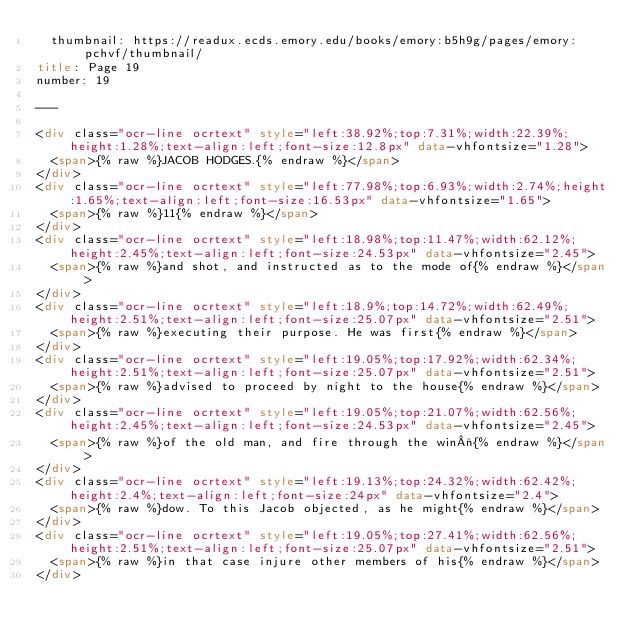Convert code to text. <code><loc_0><loc_0><loc_500><loc_500><_HTML_>  thumbnail: https://readux.ecds.emory.edu/books/emory:b5h9g/pages/emory:pchvf/thumbnail/
title: Page 19
number: 19

---

<div class="ocr-line ocrtext" style="left:38.92%;top:7.31%;width:22.39%;height:1.28%;text-align:left;font-size:12.8px" data-vhfontsize="1.28">
  <span>{% raw %}JACOB HODGES.{% endraw %}</span>
</div>
<div class="ocr-line ocrtext" style="left:77.98%;top:6.93%;width:2.74%;height:1.65%;text-align:left;font-size:16.53px" data-vhfontsize="1.65">
  <span>{% raw %}11{% endraw %}</span>
</div>
<div class="ocr-line ocrtext" style="left:18.98%;top:11.47%;width:62.12%;height:2.45%;text-align:left;font-size:24.53px" data-vhfontsize="2.45">
  <span>{% raw %}and shot, and instructed as to the mode of{% endraw %}</span>
</div>
<div class="ocr-line ocrtext" style="left:18.9%;top:14.72%;width:62.49%;height:2.51%;text-align:left;font-size:25.07px" data-vhfontsize="2.51">
  <span>{% raw %}executing their purpose. He was first{% endraw %}</span>
</div>
<div class="ocr-line ocrtext" style="left:19.05%;top:17.92%;width:62.34%;height:2.51%;text-align:left;font-size:25.07px" data-vhfontsize="2.51">
  <span>{% raw %}advised to proceed by night to the house{% endraw %}</span>
</div>
<div class="ocr-line ocrtext" style="left:19.05%;top:21.07%;width:62.56%;height:2.45%;text-align:left;font-size:24.53px" data-vhfontsize="2.45">
  <span>{% raw %}of the old man, and fire through the win¬{% endraw %}</span>
</div>
<div class="ocr-line ocrtext" style="left:19.13%;top:24.32%;width:62.42%;height:2.4%;text-align:left;font-size:24px" data-vhfontsize="2.4">
  <span>{% raw %}dow. To this Jacob objected, as he might{% endraw %}</span>
</div>
<div class="ocr-line ocrtext" style="left:19.05%;top:27.41%;width:62.56%;height:2.51%;text-align:left;font-size:25.07px" data-vhfontsize="2.51">
  <span>{% raw %}in that case injure other members of his{% endraw %}</span>
</div></code> 